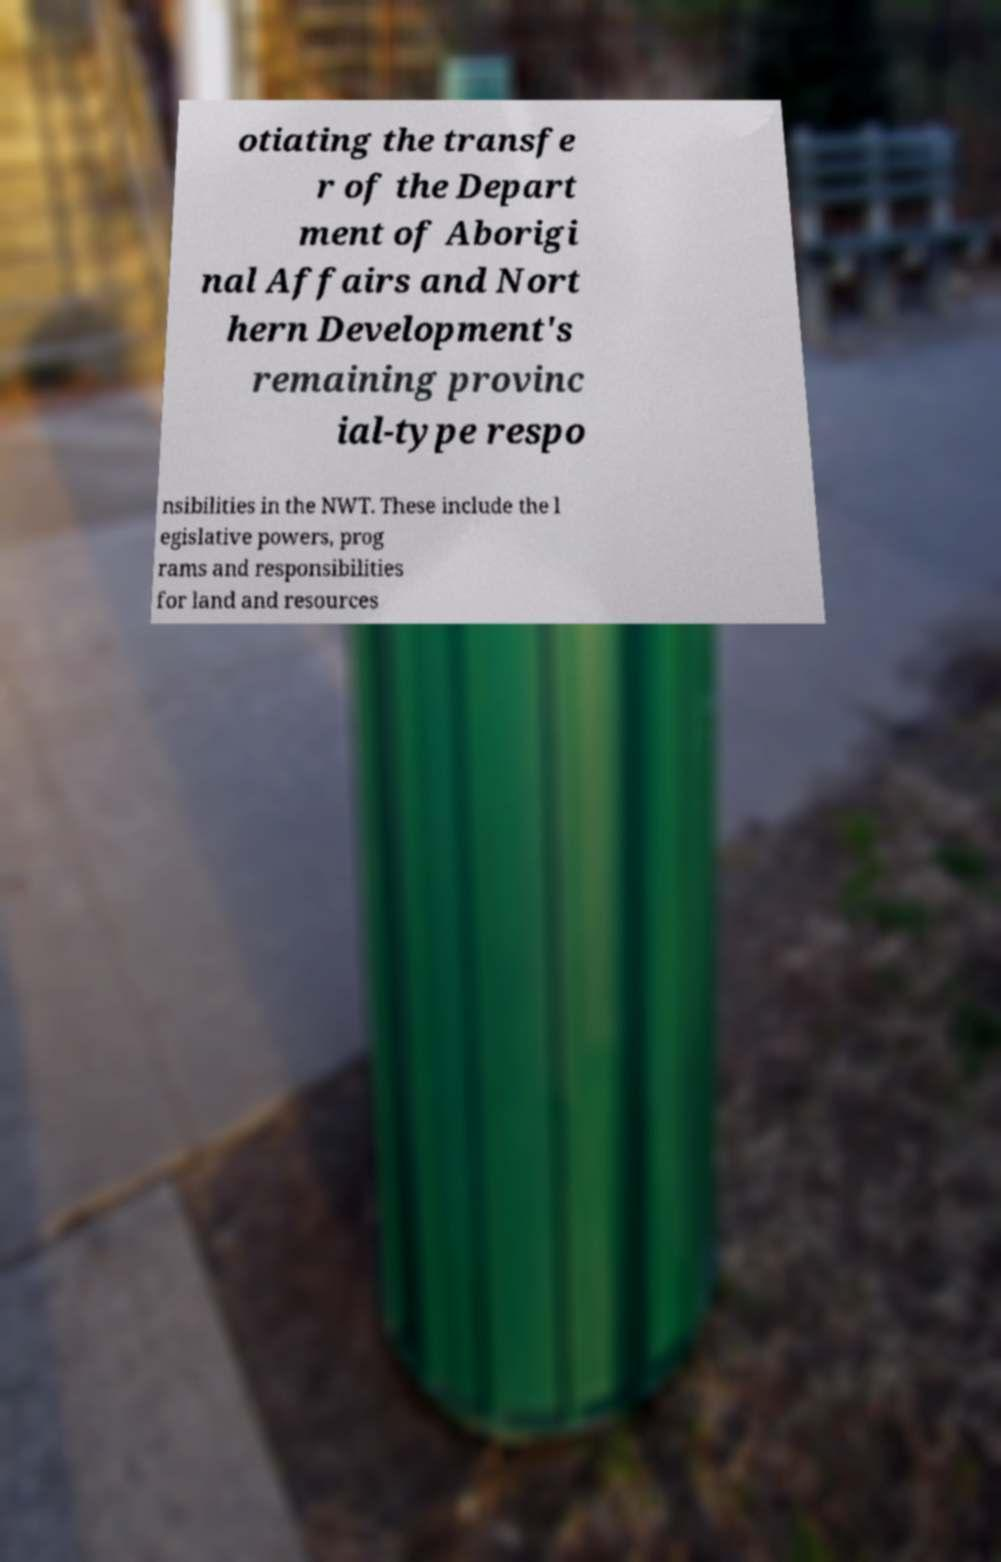Can you read and provide the text displayed in the image?This photo seems to have some interesting text. Can you extract and type it out for me? otiating the transfe r of the Depart ment of Aborigi nal Affairs and Nort hern Development's remaining provinc ial-type respo nsibilities in the NWT. These include the l egislative powers, prog rams and responsibilities for land and resources 